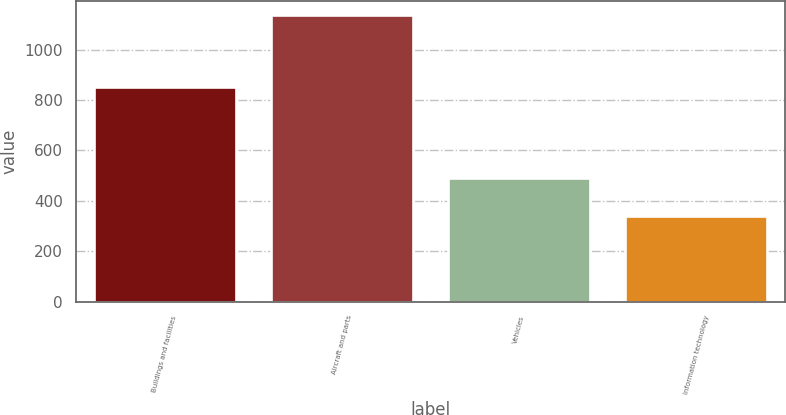<chart> <loc_0><loc_0><loc_500><loc_500><bar_chart><fcel>Buildings and facilities<fcel>Aircraft and parts<fcel>Vehicles<fcel>Information technology<nl><fcel>853<fcel>1137<fcel>492<fcel>338<nl></chart> 